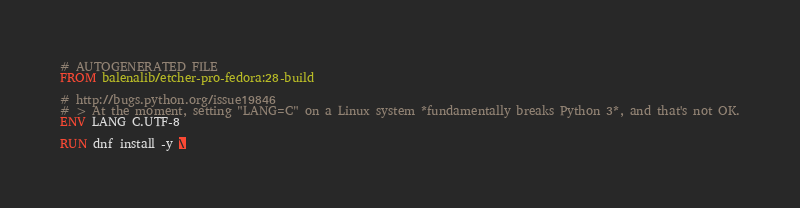Convert code to text. <code><loc_0><loc_0><loc_500><loc_500><_Dockerfile_># AUTOGENERATED FILE
FROM balenalib/etcher-pro-fedora:28-build

# http://bugs.python.org/issue19846
# > At the moment, setting "LANG=C" on a Linux system *fundamentally breaks Python 3*, and that's not OK.
ENV LANG C.UTF-8

RUN dnf install -y \</code> 